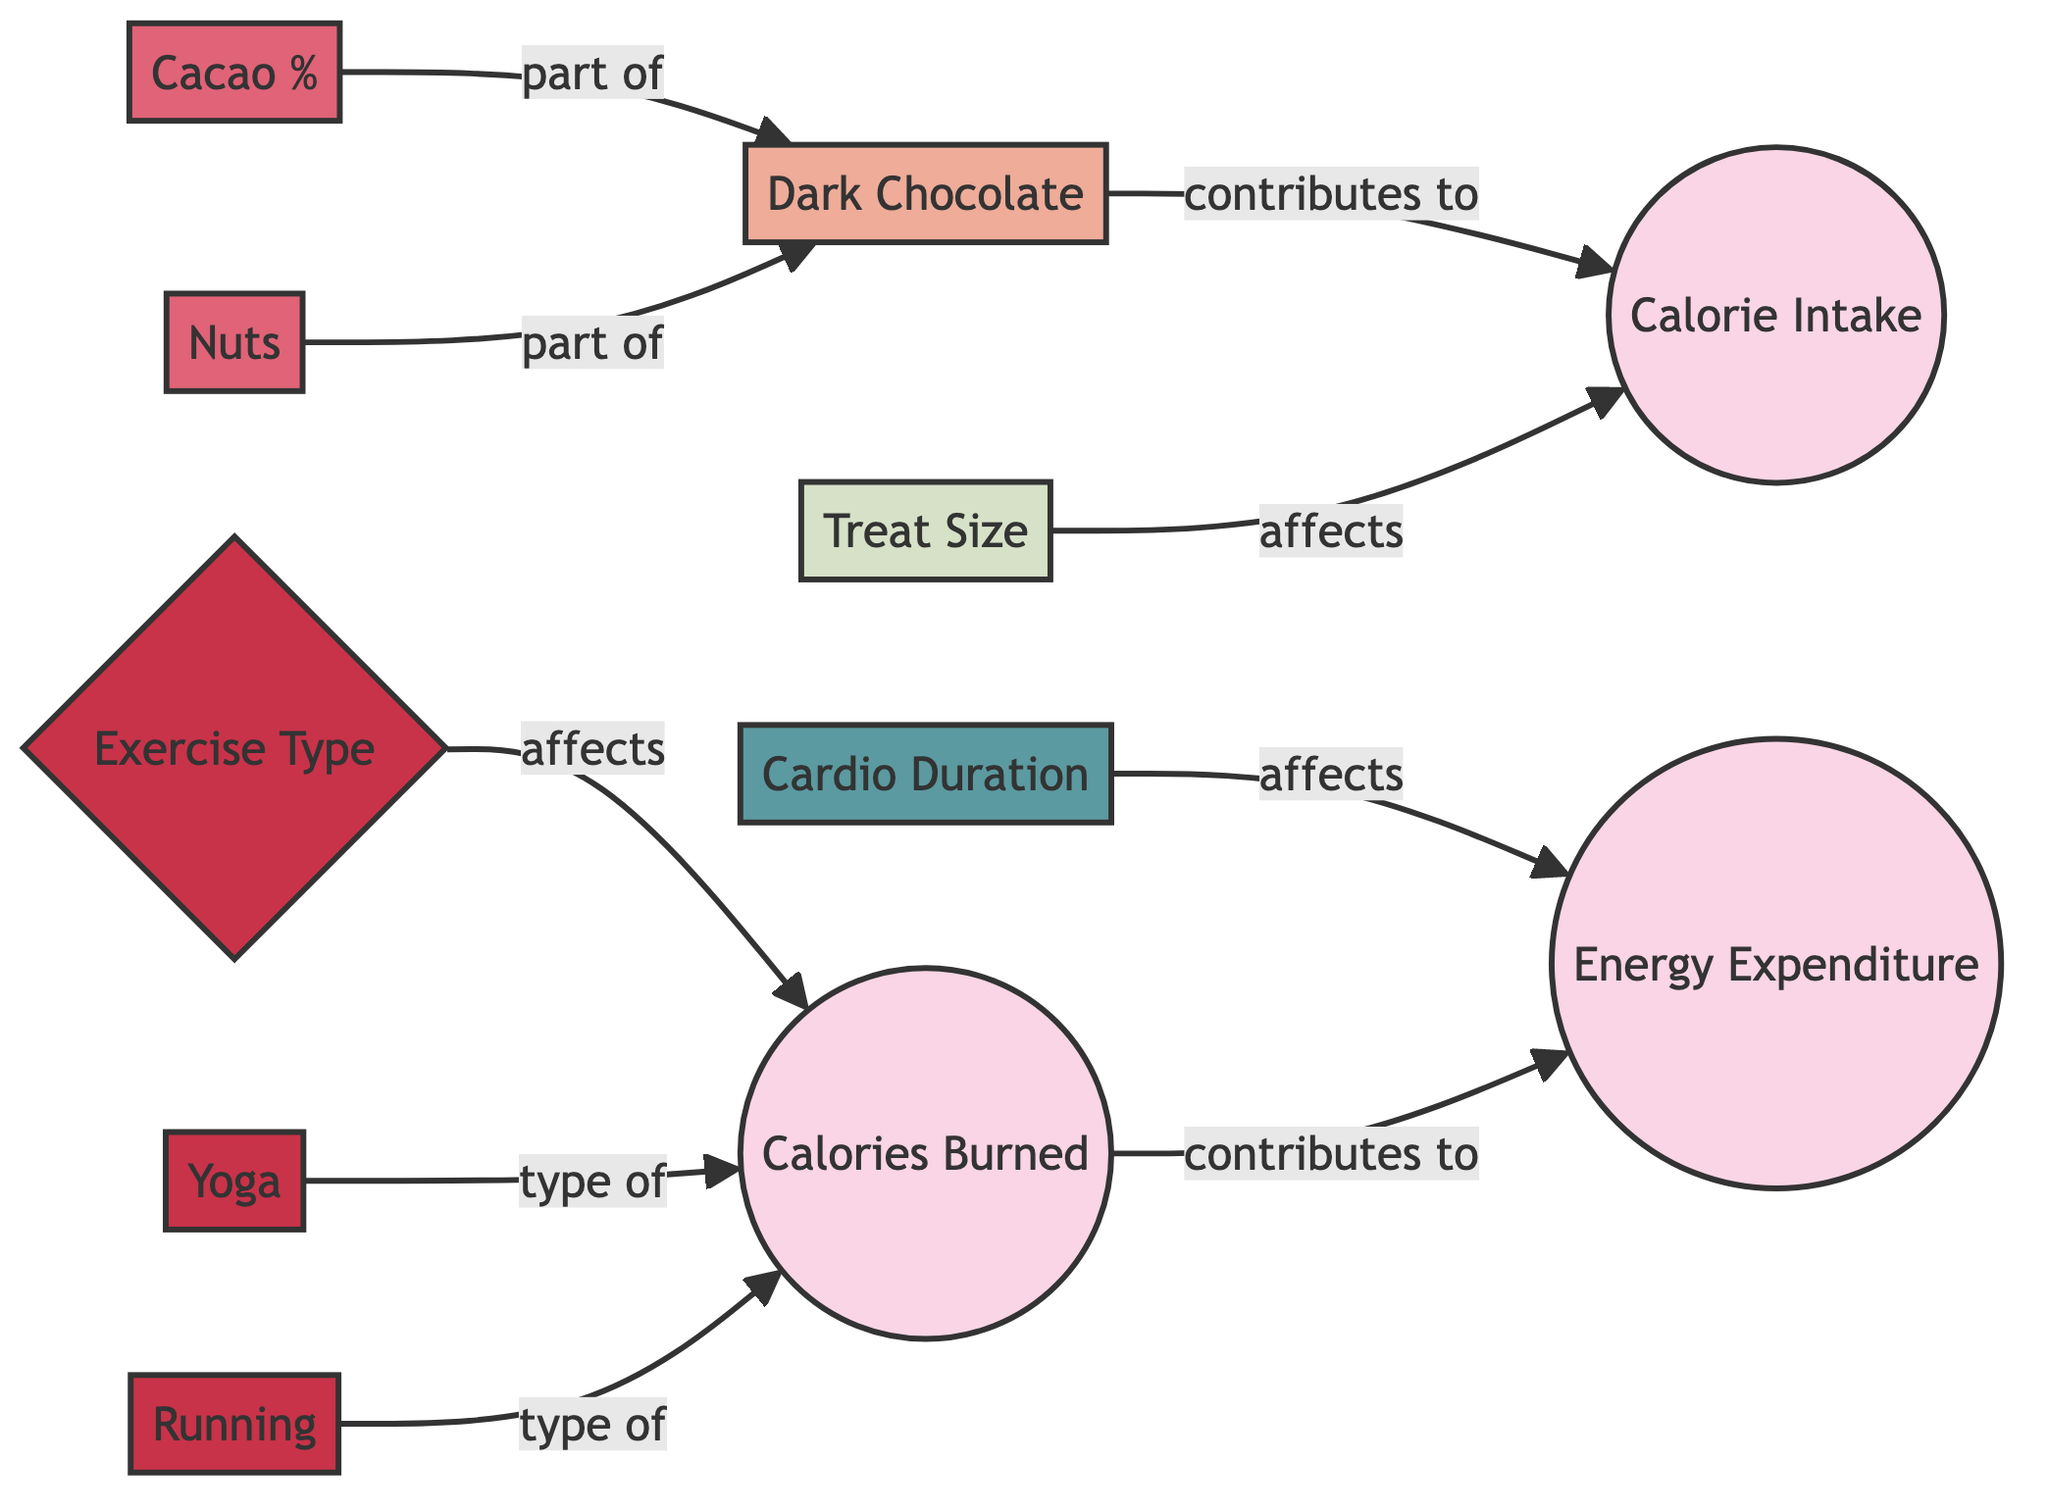What is the relationship between dark chocolate and calorie intake? The diagram indicates that dark chocolate contributes to calorie intake. This is shown by the arrow connecting "dark_chocolate" to "calorie_intake" labeled as "contributes to".
Answer: contributes to How many ingredients are part of dark chocolate? There are two ingredients indicated in the diagram connected to dark chocolate: cacao percentage and nuts. The connections are shown with arrows labeled as "part of".
Answer: two Which specific activities contribute to calories burned? The diagram indicates that yoga and running are types of exercise that contribute to calories burned, as both are connected to the “calories_burned” node by arrows labeled "type of".
Answer: yoga, running What affects energy expenditure according to the diagram? Energy expenditure is affected by cardio duration and calories burned. This can be determined by tracing the arrows; "cardio_duration" connects to "energy_expenditure" labeled as "affects", and "calories_burned" connects to "energy_expenditure" labeled as "contributes to".
Answer: cardio duration, calories burned What is the role of treat size in calorie intake? The treat size directly affects calorie intake, as shown by the arrow from "treat_size" to "calorie_intake" indicating its influence with the label "affects".
Answer: affects How does exercise type influence calories burned? Exercise type influences calories burned through the relationship shown in the diagram where "exercise_type" connects to "calories_burned" labeled as "affects". This means different types of exercise impact the calories burned differently.
Answer: affects Which ingredient has a direct relationship with dark chocolate? Both cacao percentage and nuts have direct relationships with dark chocolate, as indicated by the arrows labeled "part of" connecting them to the "dark_chocolate" node.
Answer: cacao percentage, nuts What contributes to energy expenditure? Calories burned contributes to energy expenditure. This is depicted in the diagram where "calories_burned" connects to "energy_expenditure" with the label "contributes to".
Answer: calories burned 